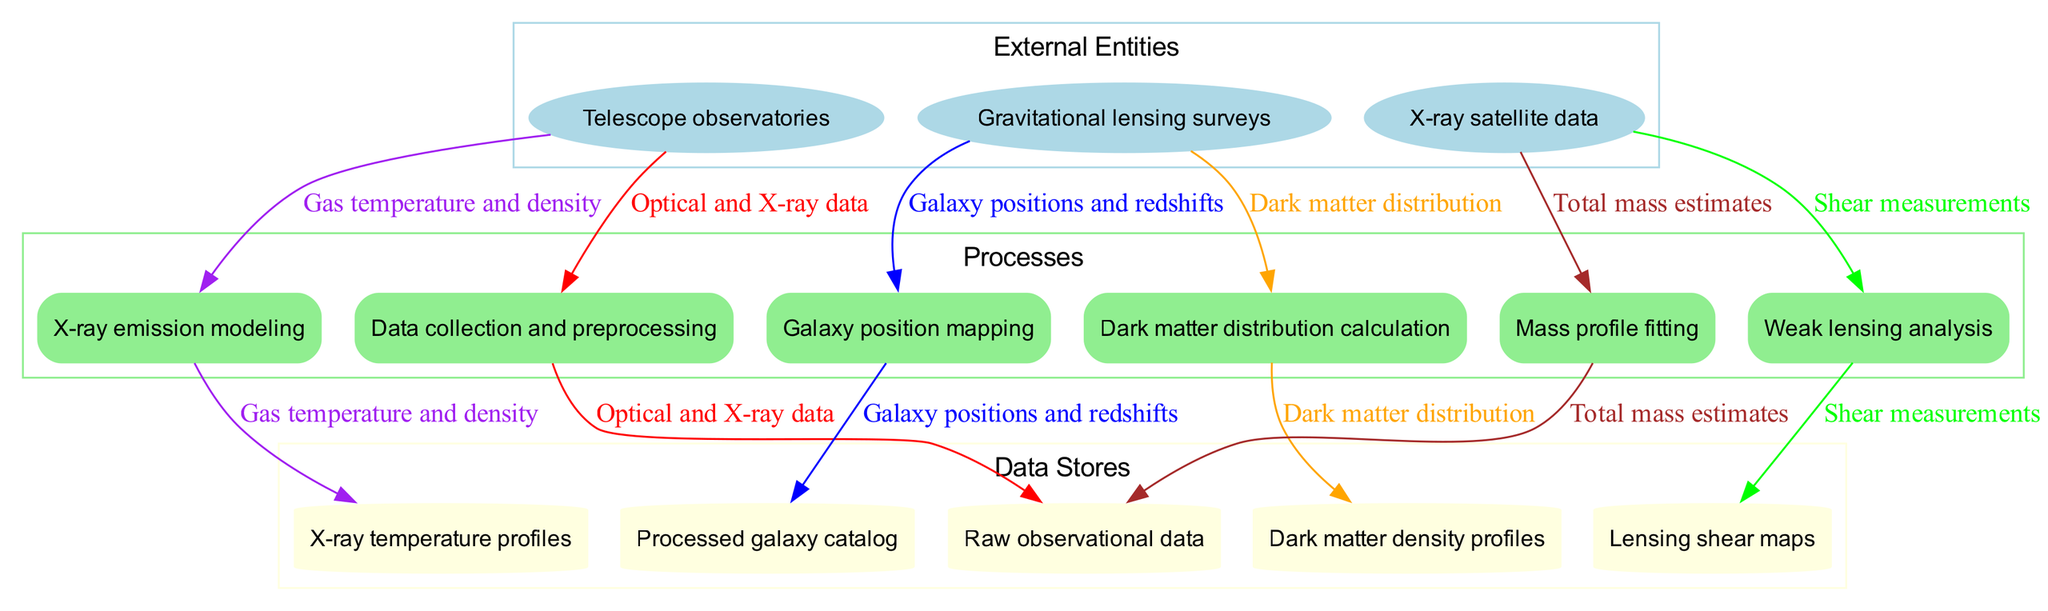What are the external entities in this diagram? The external entities in the diagram are noted within the ellipse-shaped nodes. These include telescope observatories, gravitational lensing surveys, and X-ray satellite data, as listed in the description of the external entity nodes.
Answer: Telescope observatories, gravitational lensing surveys, X-ray satellite data How many processes are defined in this workflow? By counting the rectangle-shaped nodes labeled as processes in the diagram, we can see there are six distinct processes included in the description of the process nodes.
Answer: Six What type of data is flowing from 'Data collection and preprocessing' to 'Processed galaxy catalog'? The edge leading from 'Data collection and preprocessing' to 'Processed galaxy catalog' node is labeled with a specific type of data mentioned in the diagram, which pertains to the processed data as a result of the earlier process.
Answer: Processed galaxy catalog Which data store receives shear measurements? By examining the edges connected from the 'Weak lensing analysis' process, we can identify that the output labeled shear measurements flows into the 'Lensing shear maps' data store node specifically.
Answer: Lensing shear maps What is the last process that calculates the dark matter distribution? The last process in the sequence specifically dedicated to calculating dark matter distribution is outlined at this position in the diagram, which directly comes after the previous processes in the flow.
Answer: Dark matter distribution calculation How many data flows originate from external entities? Observing the connections from external entities to processes, we note that there are a total of three distinct external entities, indicating three direct flows originate from them in the diagram's flow structure.
Answer: Three What is the main purpose of the 'Mass profile fitting' process? The 'Mass profile fitting' process is positioned last in the workflow and connects to the calculation of total mass estimates, indicating its main purpose is to analyze and fit mass profiles based on previously calculated density profiles.
Answer: Analyze mass profiles What are the two main types of observational data indicated in the workflow? The two primary types of observational data recognized from the external entities' connections which flow into processes include optical data from telescope observatories and X-ray data from X-ray satellite data, both essential for the analysis.
Answer: Optical data, X-ray data 